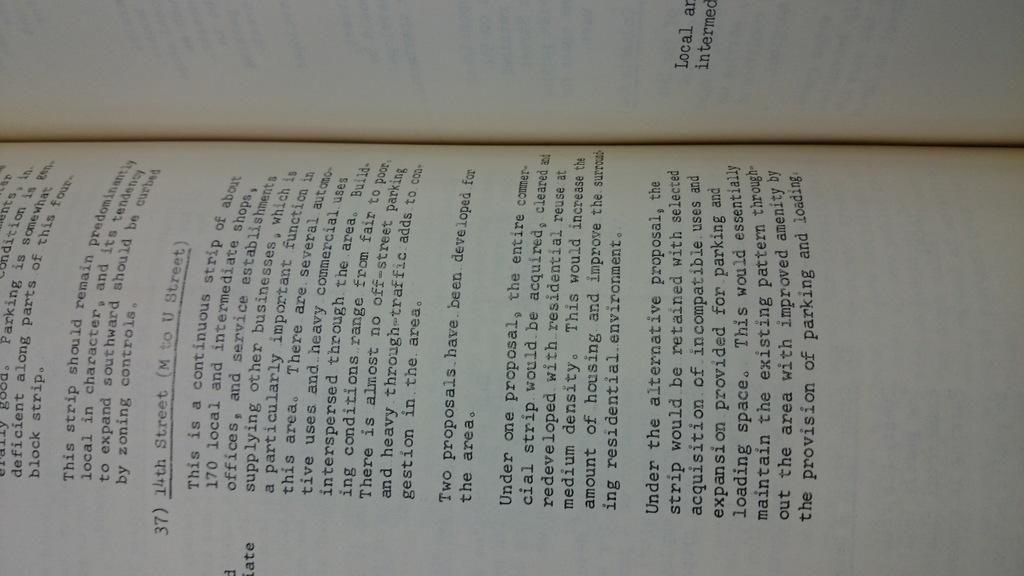What street number is this section of the book about?
Provide a short and direct response. 14th. Which chapter is this?
Your answer should be very brief. 37. 